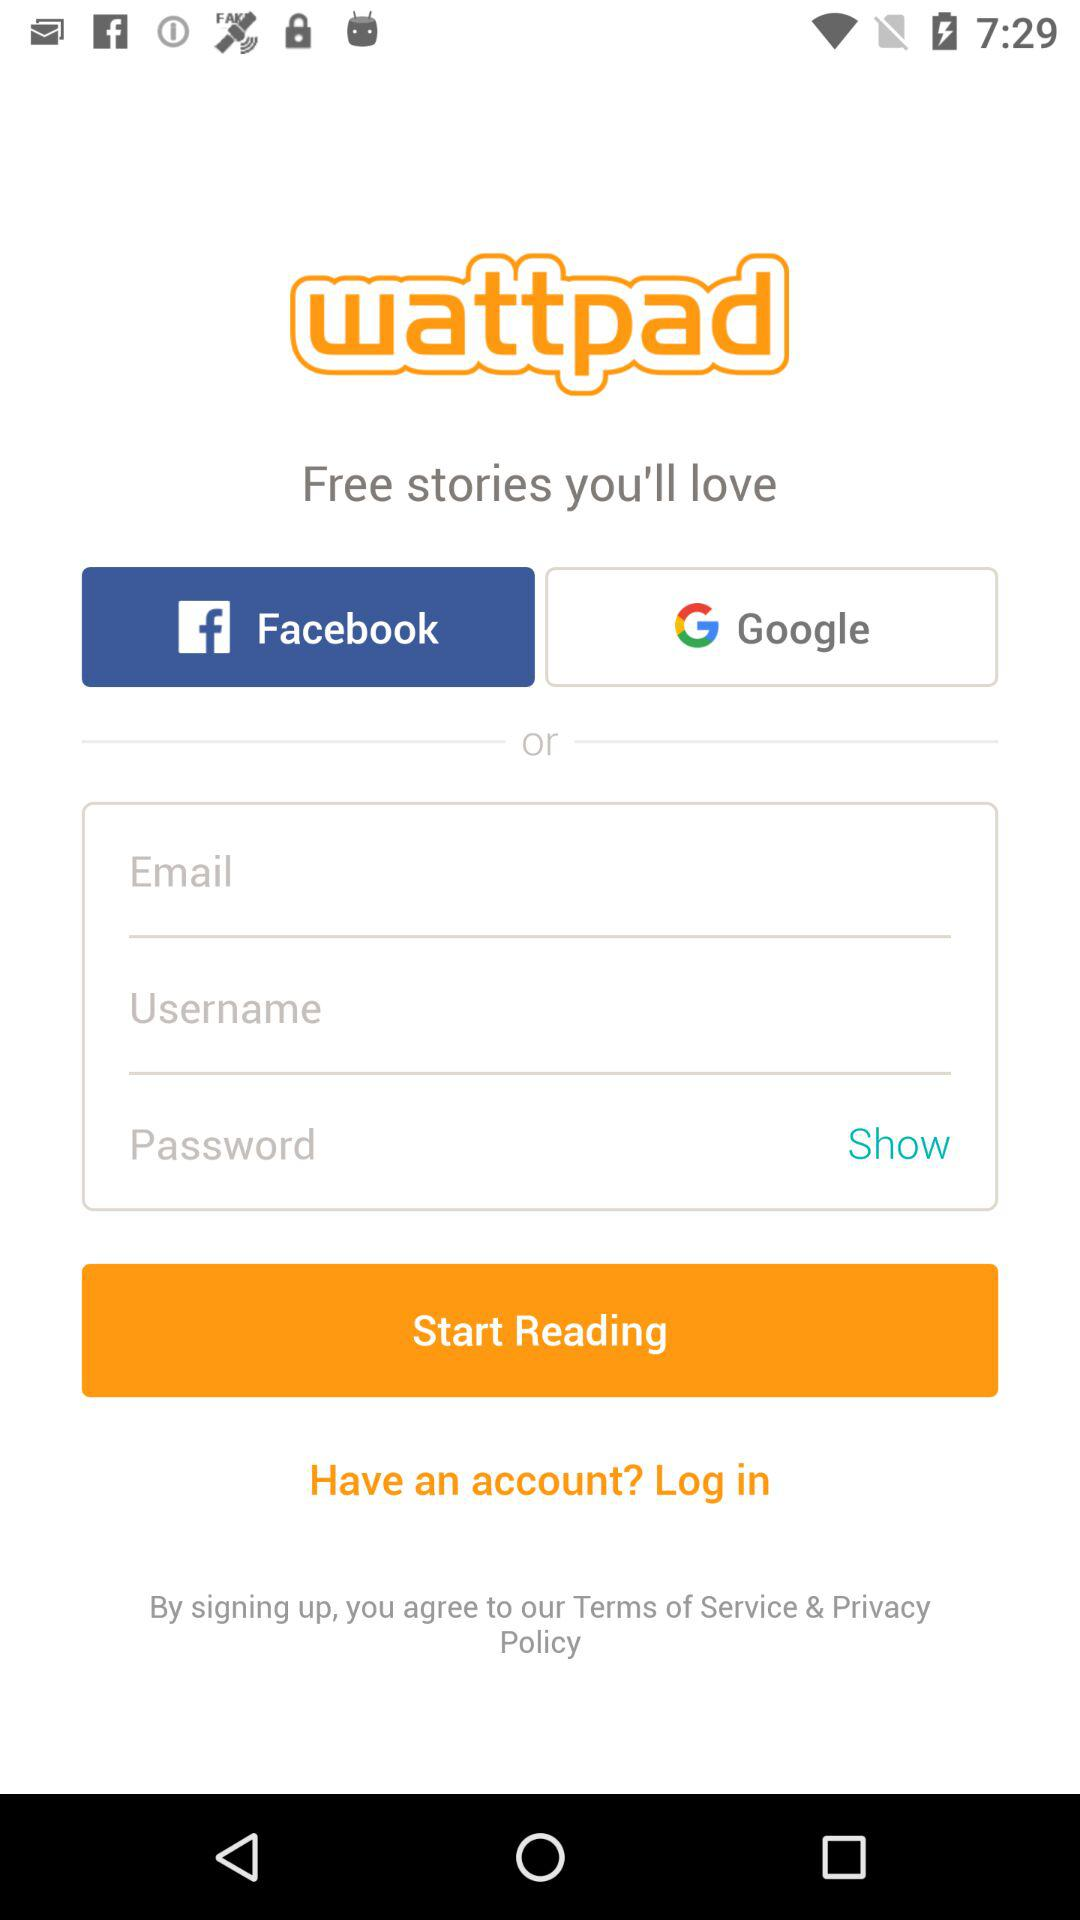What is the application name? The application name is "wattpad". 